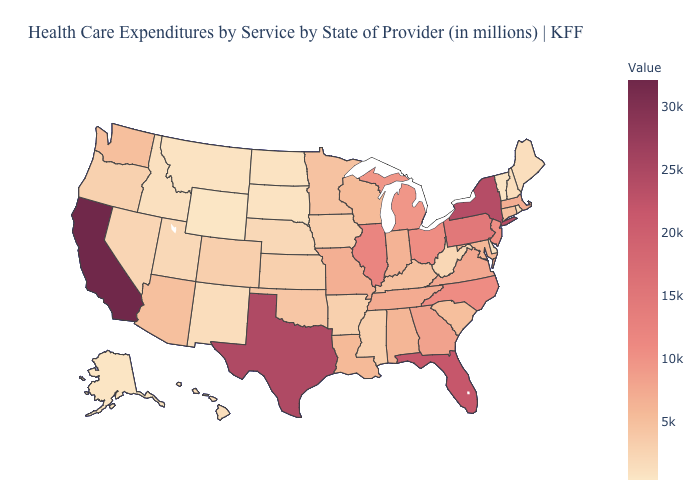Is the legend a continuous bar?
Answer briefly. Yes. Among the states that border Mississippi , which have the lowest value?
Answer briefly. Arkansas. Does Colorado have the lowest value in the West?
Answer briefly. No. Does California have the highest value in the West?
Give a very brief answer. Yes. Is the legend a continuous bar?
Be succinct. Yes. 